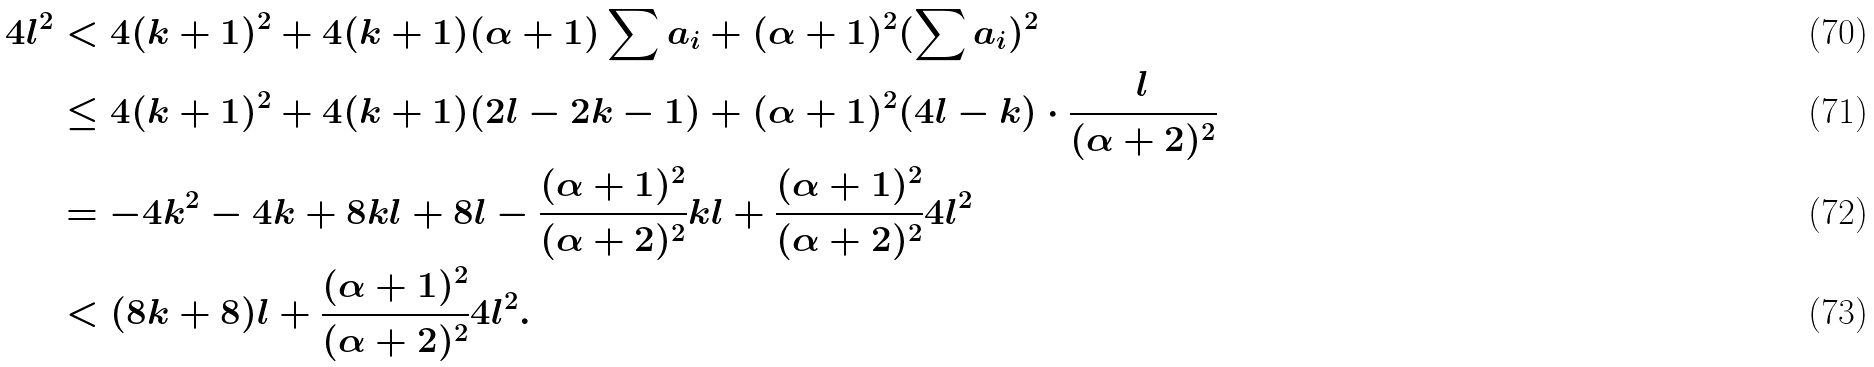<formula> <loc_0><loc_0><loc_500><loc_500>4 l ^ { 2 } & < 4 ( k + 1 ) ^ { 2 } + 4 ( k + 1 ) ( \alpha + 1 ) \sum a _ { i } + ( \alpha + 1 ) ^ { 2 } ( \sum a _ { i } ) ^ { 2 } \\ & \leq 4 ( k + 1 ) ^ { 2 } + 4 ( k + 1 ) ( 2 l - 2 k - 1 ) + ( \alpha + 1 ) ^ { 2 } ( 4 l - k ) \cdot \frac { l } { ( \alpha + 2 ) ^ { 2 } } \\ & = - 4 k ^ { 2 } - 4 k + 8 k l + 8 l - \frac { ( \alpha + 1 ) ^ { 2 } } { ( \alpha + 2 ) ^ { 2 } } k l + \frac { ( \alpha + 1 ) ^ { 2 } } { ( \alpha + 2 ) ^ { 2 } } 4 l ^ { 2 } \\ & < ( 8 k + 8 ) l + \frac { ( \alpha + 1 ) ^ { 2 } } { ( \alpha + 2 ) ^ { 2 } } 4 l ^ { 2 } .</formula> 